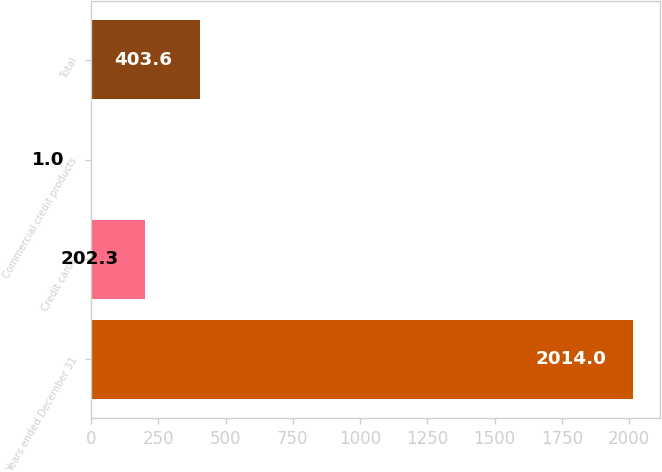<chart> <loc_0><loc_0><loc_500><loc_500><bar_chart><fcel>Years ended December 31<fcel>Credit cards<fcel>Commercial credit products<fcel>Total<nl><fcel>2014<fcel>202.3<fcel>1<fcel>403.6<nl></chart> 